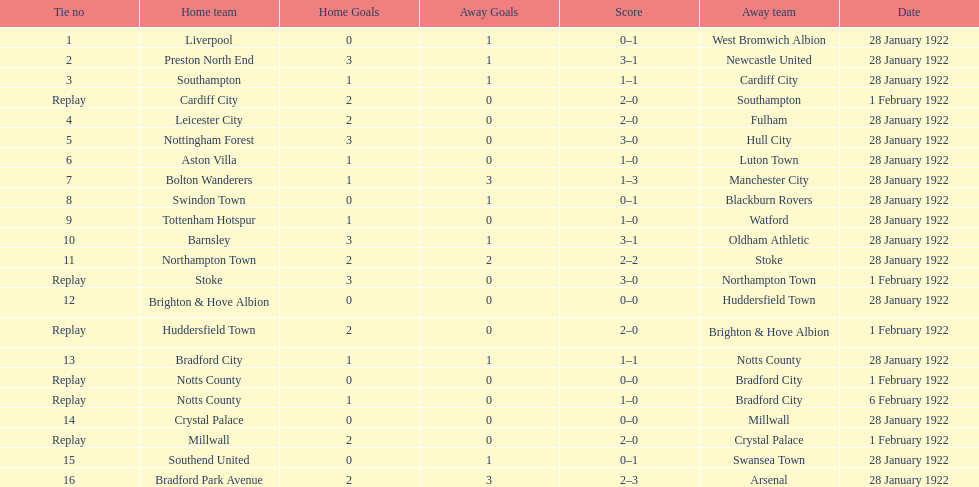What home team had the same score as aston villa on january 28th, 1922? Tottenham Hotspur. 